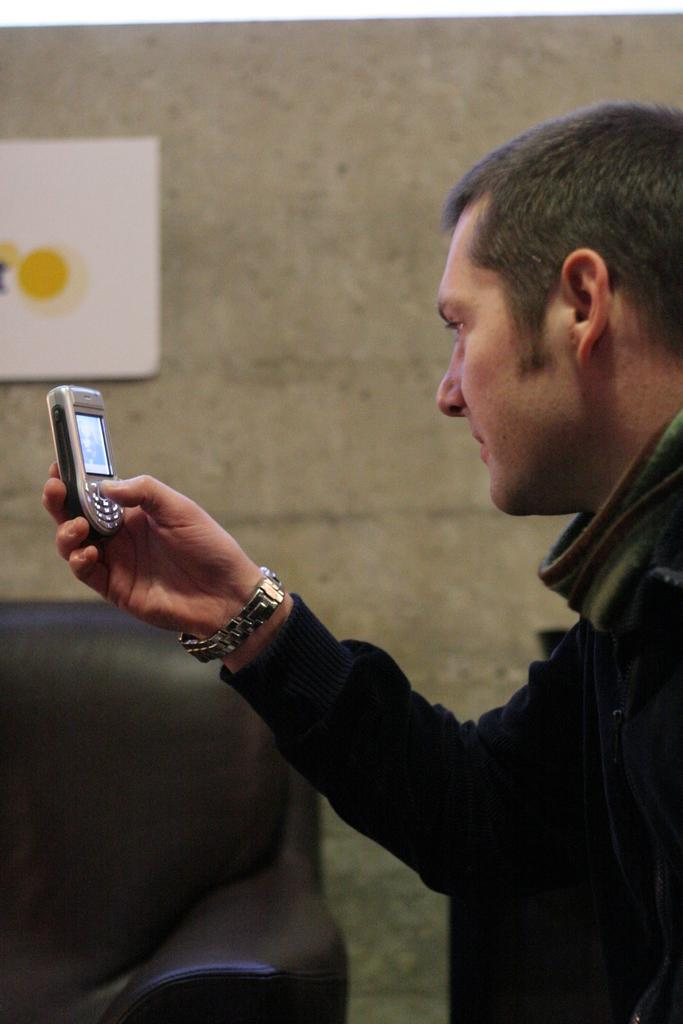Who is present in the image? There is a man in the image. What is the man wearing? The man is wearing a watch. What is the man holding in the image? The man is holding a mobile. What can be seen in the background of the image? There is a couch, a wall, and a board in the background of the image. What type of alley can be seen in the background of the image? There is no alley present in the image; it features a man holding a mobile, a couch, a wall, and a board in the background. 